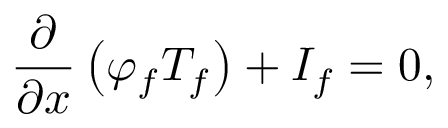Convert formula to latex. <formula><loc_0><loc_0><loc_500><loc_500>\frac { \partial } { \partial x } \left ( \varphi _ { f } T _ { f } \right ) + I _ { f } = 0 ,</formula> 